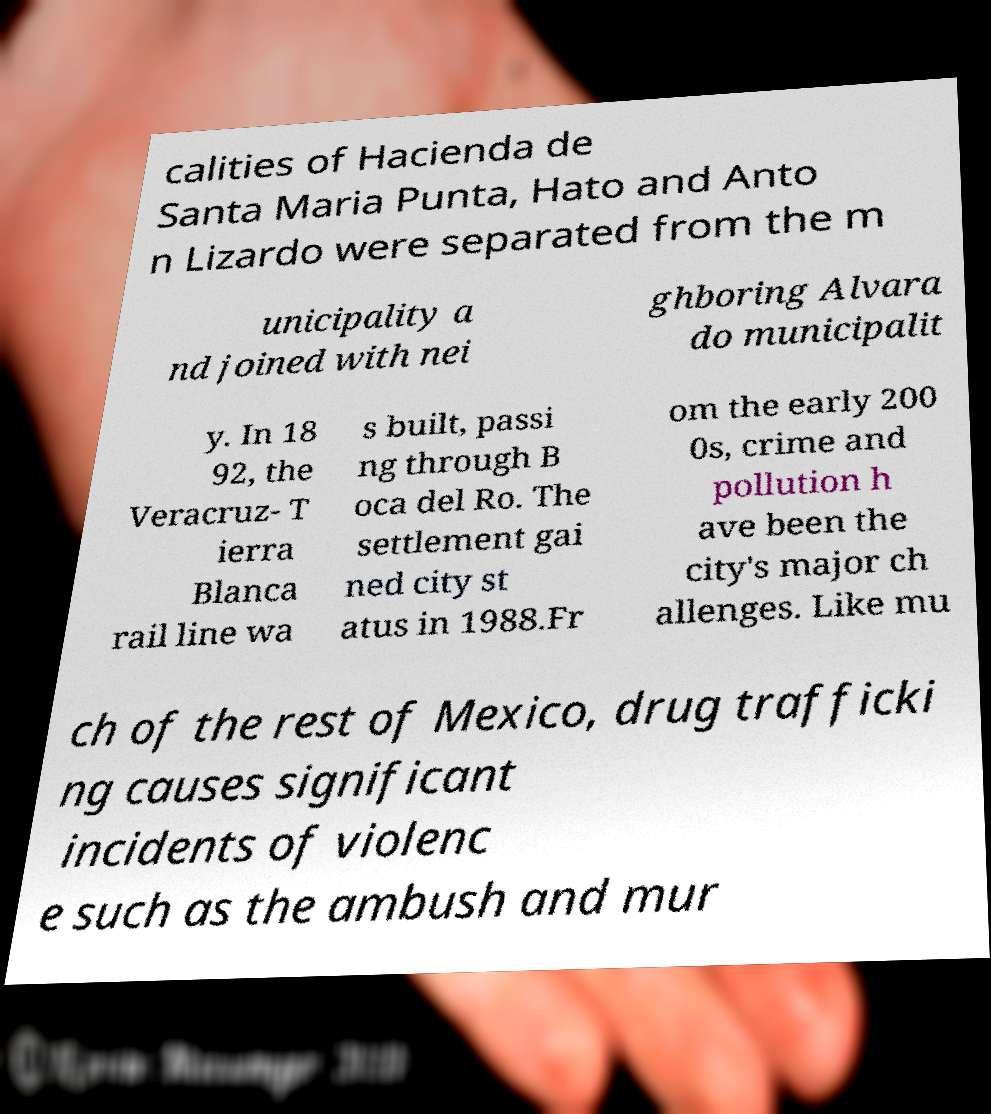Can you read and provide the text displayed in the image?This photo seems to have some interesting text. Can you extract and type it out for me? calities of Hacienda de Santa Maria Punta, Hato and Anto n Lizardo were separated from the m unicipality a nd joined with nei ghboring Alvara do municipalit y. In 18 92, the Veracruz- T ierra Blanca rail line wa s built, passi ng through B oca del Ro. The settlement gai ned city st atus in 1988.Fr om the early 200 0s, crime and pollution h ave been the city's major ch allenges. Like mu ch of the rest of Mexico, drug trafficki ng causes significant incidents of violenc e such as the ambush and mur 